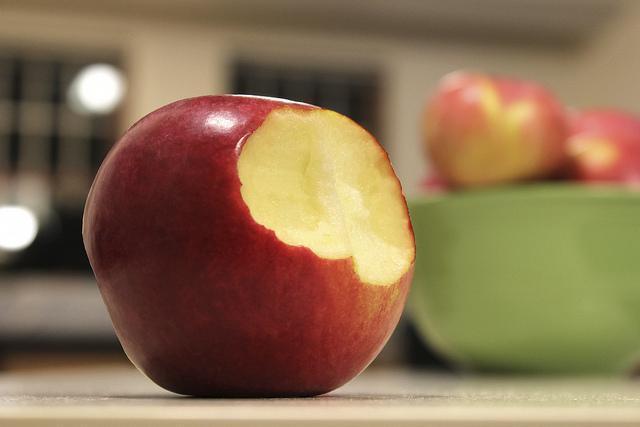How many apples are in the image?
Give a very brief answer. 4. How many bowls are in the picture?
Give a very brief answer. 1. How many apples can be seen?
Give a very brief answer. 2. 